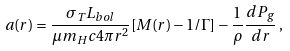Convert formula to latex. <formula><loc_0><loc_0><loc_500><loc_500>a ( r ) = \frac { \sigma _ { T } L _ { b o l } } { \mu m _ { H } c 4 \pi r ^ { 2 } } [ M ( r ) - 1 / \Gamma ] - \frac { 1 } { \rho } \frac { d P _ { g } } { d r } \, ,</formula> 